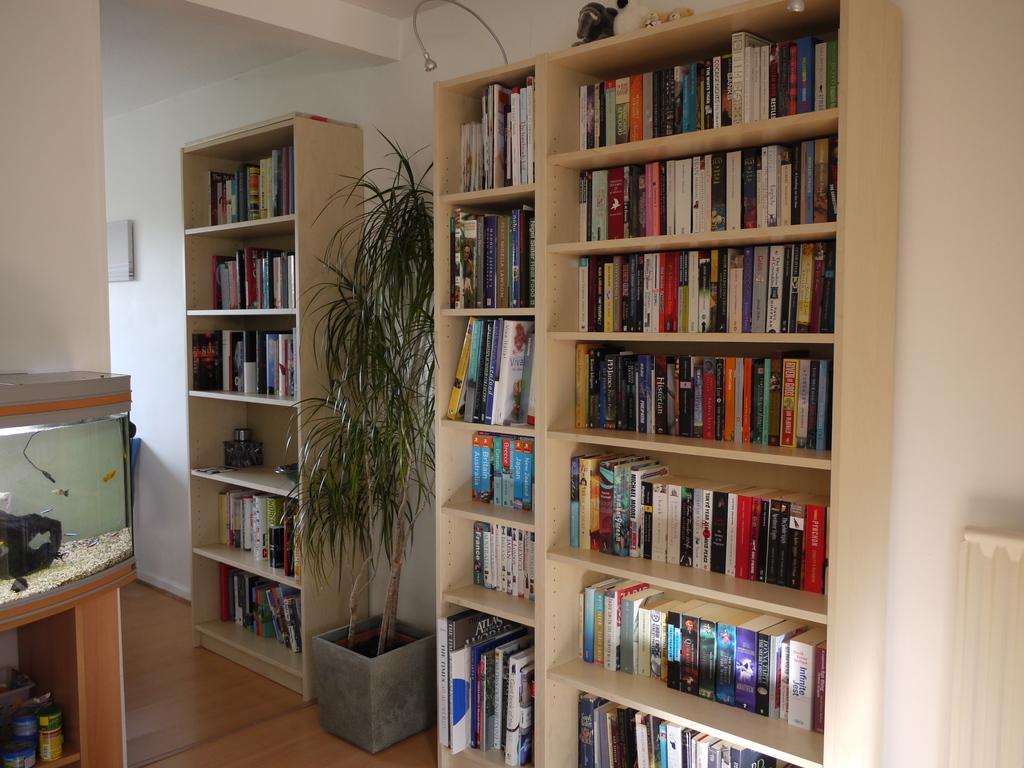Could you give a brief overview of what you see in this image? In this image, we can see some racks, there are some books kept in the racks, we can see a flower pot and a plant, we can see the wall. 